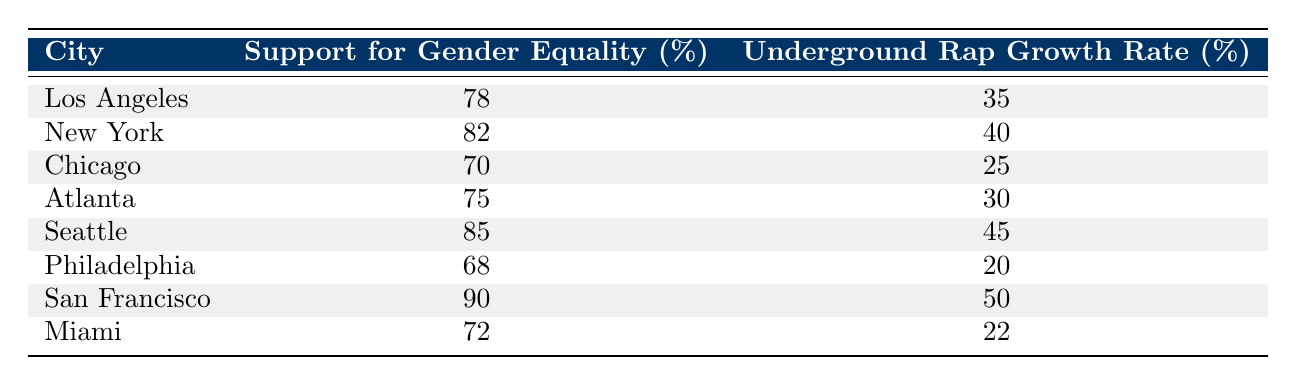What is the highest support for gender equality percentage? The highest support for gender equality percentage in the table is found in San Francisco, which has a percentage of 90.
Answer: 90 Which city has the lowest underground rap growth rate? The city with the lowest underground rap growth rate is Philadelphia, with a growth rate of 20.
Answer: 20 Is the percentage of support for gender equality in Chicago greater than 70? The support for gender equality in Chicago is 70, which is not greater than 70, therefore the answer is no.
Answer: No What is the average underground rap growth rate for all cities listed? To calculate the average, sum the underground rap growth rates: 35 + 40 + 25 + 30 + 45 + 20 + 50 + 22 = 267. There are 8 cities, so the average is 267/8 = 33.375.
Answer: 33.375 Which city with support for gender equality above 75 has the highest underground rap growth rate? The cities with support for gender equality above 75 are New York, Seattle, and San Francisco. Among these, San Francisco has the highest underground rap growth rate at 50.
Answer: San Francisco How many cities have a support for gender equality percentage lower than 75? The cities with support for gender equality lower than 75 are Chicago (70), Philadelphia (68), and Miami (72), totaling three cities.
Answer: 3 What is the difference in underground rap growth rate between the city with the highest and lowest support for gender equality? The city with the highest support for gender equality is San Francisco (90) and the lowest is Philadelphia (68). The underground rap growth rates are 50 and 20 respectively, so the difference is 50 - 20 = 30.
Answer: 30 Is there a positive correlation between support for gender equality and underground rap growth rate based on the table? By observing the general trend, as support for gender equality increases, underground rap growth rates appear to increase as well. This suggests a positive correlation, though further statistical analysis is beyond the table's data.
Answer: Yes 